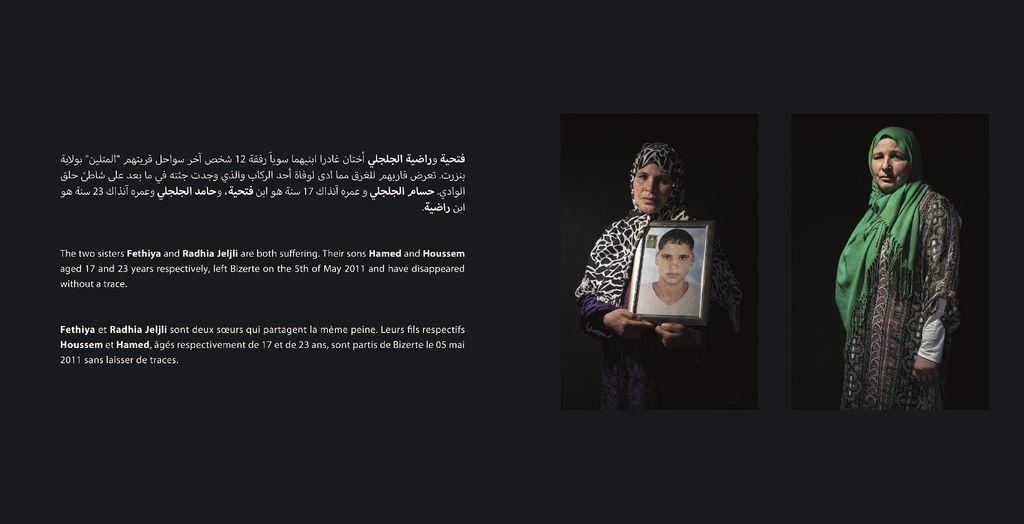How many people are present in the image? There are two women standing in the image. What is one of the women holding? One of the women is holding a photo frame. What can be seen inside the photo frame? The photo frame contains an image of a person. Is there any text visible in the image? Yes, there is text visible in the image. What type of leather is being used to make the eggnog in the image? There is no eggnog or leather present in the image. How many mines are visible in the image? There are no mines visible in the image. 